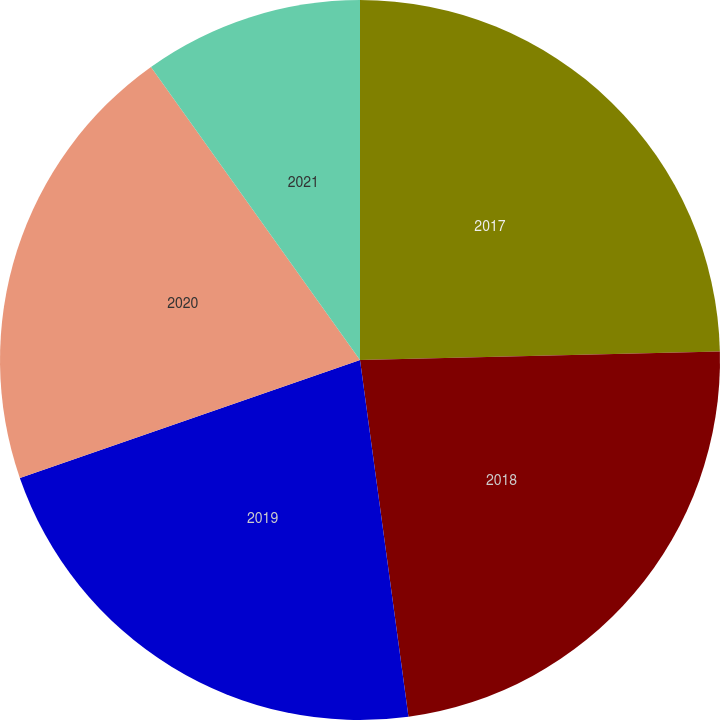<chart> <loc_0><loc_0><loc_500><loc_500><pie_chart><fcel>2017<fcel>2018<fcel>2019<fcel>2020<fcel>2021<nl><fcel>24.62%<fcel>23.23%<fcel>21.84%<fcel>20.45%<fcel>9.86%<nl></chart> 